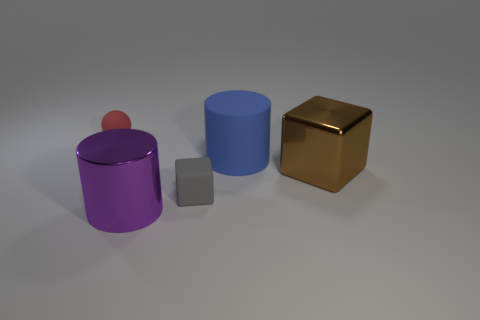Add 3 matte things. How many objects exist? 8 Subtract all cylinders. How many objects are left? 3 Subtract 0 purple cubes. How many objects are left? 5 Subtract all tiny matte spheres. Subtract all gray rubber cubes. How many objects are left? 3 Add 5 red balls. How many red balls are left? 6 Add 4 tiny yellow metal spheres. How many tiny yellow metal spheres exist? 4 